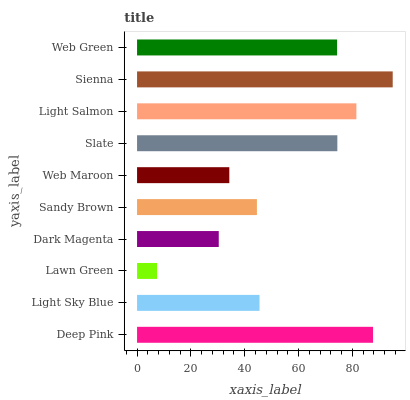Is Lawn Green the minimum?
Answer yes or no. Yes. Is Sienna the maximum?
Answer yes or no. Yes. Is Light Sky Blue the minimum?
Answer yes or no. No. Is Light Sky Blue the maximum?
Answer yes or no. No. Is Deep Pink greater than Light Sky Blue?
Answer yes or no. Yes. Is Light Sky Blue less than Deep Pink?
Answer yes or no. Yes. Is Light Sky Blue greater than Deep Pink?
Answer yes or no. No. Is Deep Pink less than Light Sky Blue?
Answer yes or no. No. Is Web Green the high median?
Answer yes or no. Yes. Is Light Sky Blue the low median?
Answer yes or no. Yes. Is Sandy Brown the high median?
Answer yes or no. No. Is Deep Pink the low median?
Answer yes or no. No. 